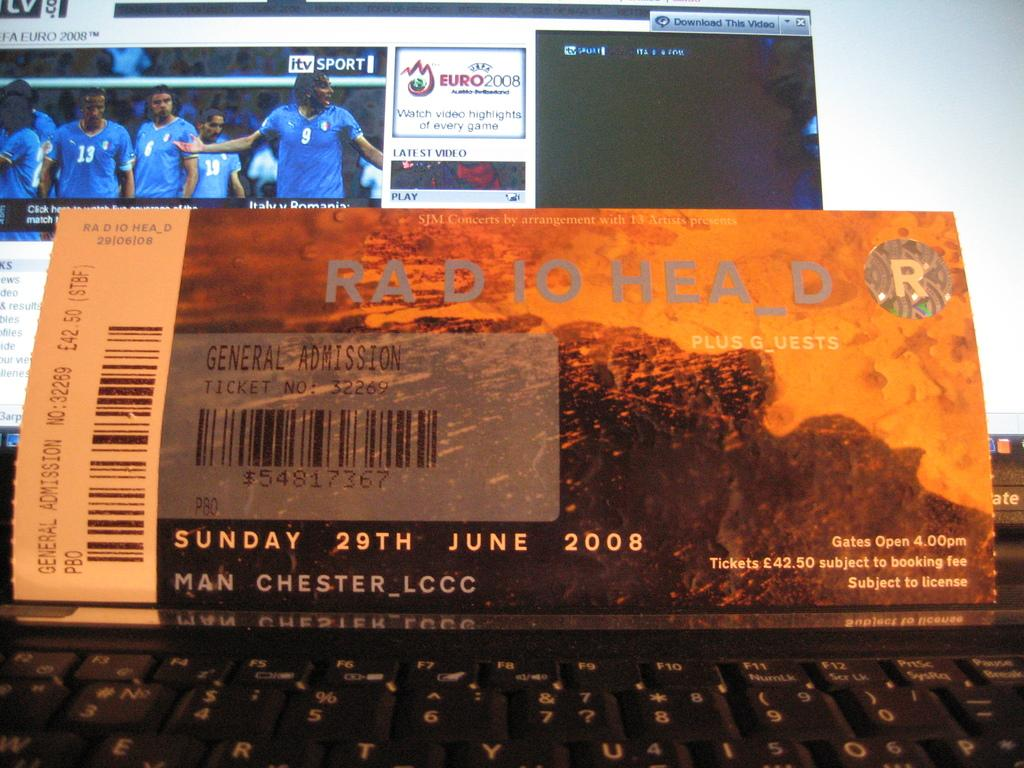<image>
Render a clear and concise summary of the photo. A ticket for Radiohead is set against a monitor screen. 